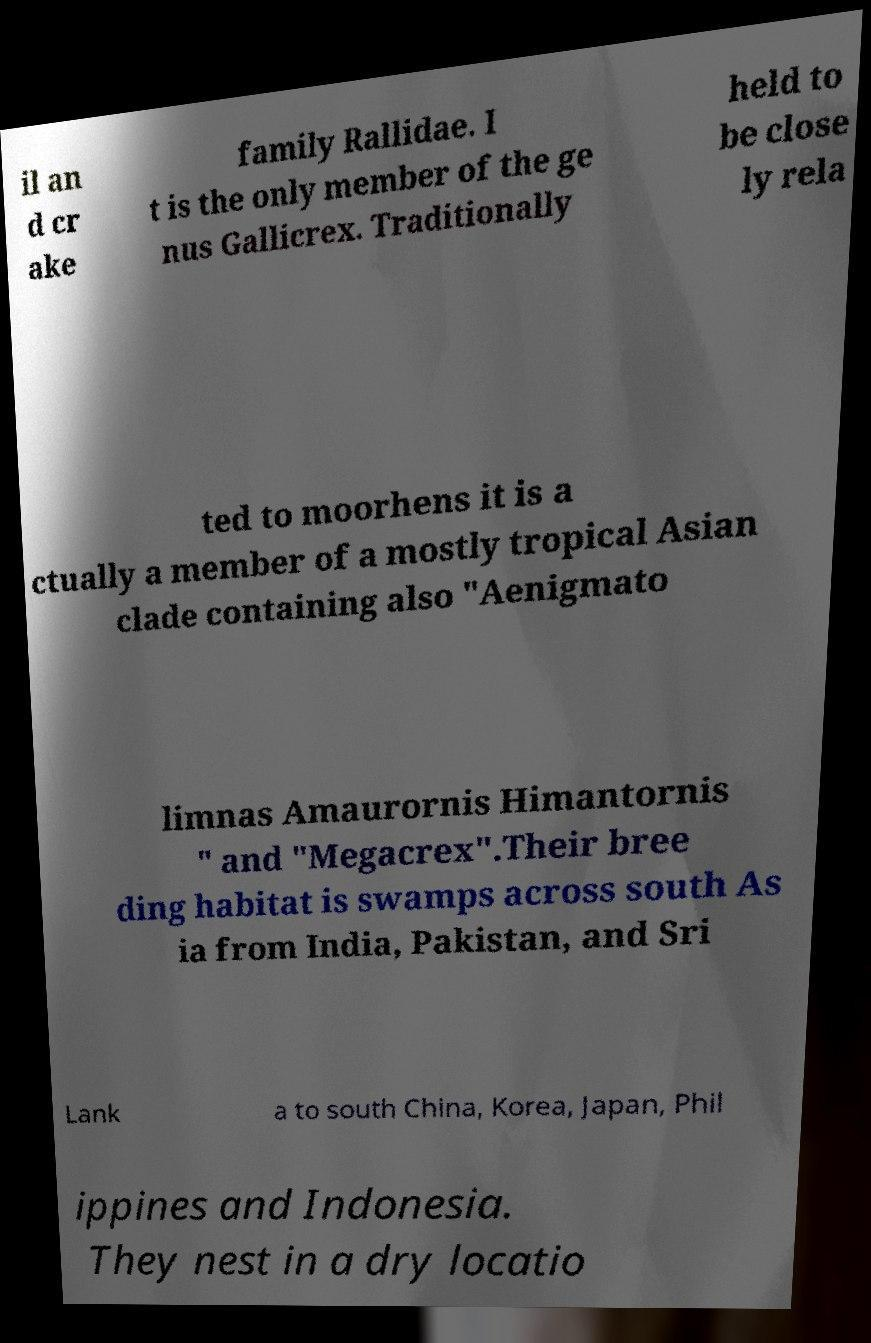I need the written content from this picture converted into text. Can you do that? il an d cr ake family Rallidae. I t is the only member of the ge nus Gallicrex. Traditionally held to be close ly rela ted to moorhens it is a ctually a member of a mostly tropical Asian clade containing also "Aenigmato limnas Amaurornis Himantornis " and "Megacrex".Their bree ding habitat is swamps across south As ia from India, Pakistan, and Sri Lank a to south China, Korea, Japan, Phil ippines and Indonesia. They nest in a dry locatio 